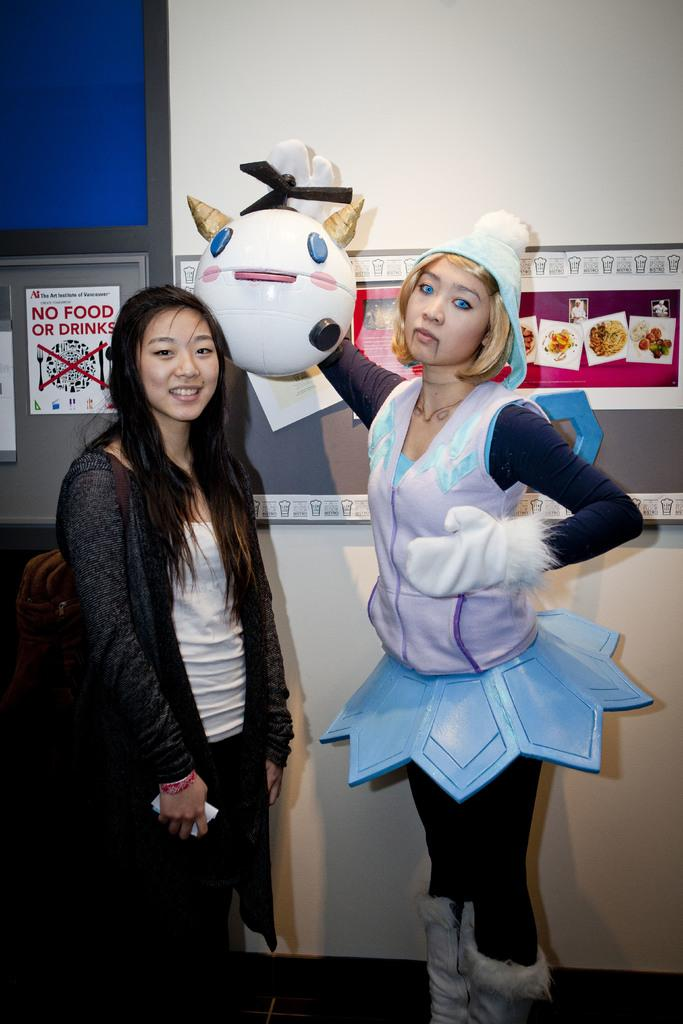How many women are present in the image? There are two women in the image. Can you describe the costumes of the women? One woman is wearing a different costume in the image. What is visible in the background of the image? There is a wall in the background of the image. What is attached to the wall in the background? Posters are attached to the wall in the background. What type of grass can be seen growing on the library floor in the image? There is no library or grass present in the image; it features two women and a wall with posters. 